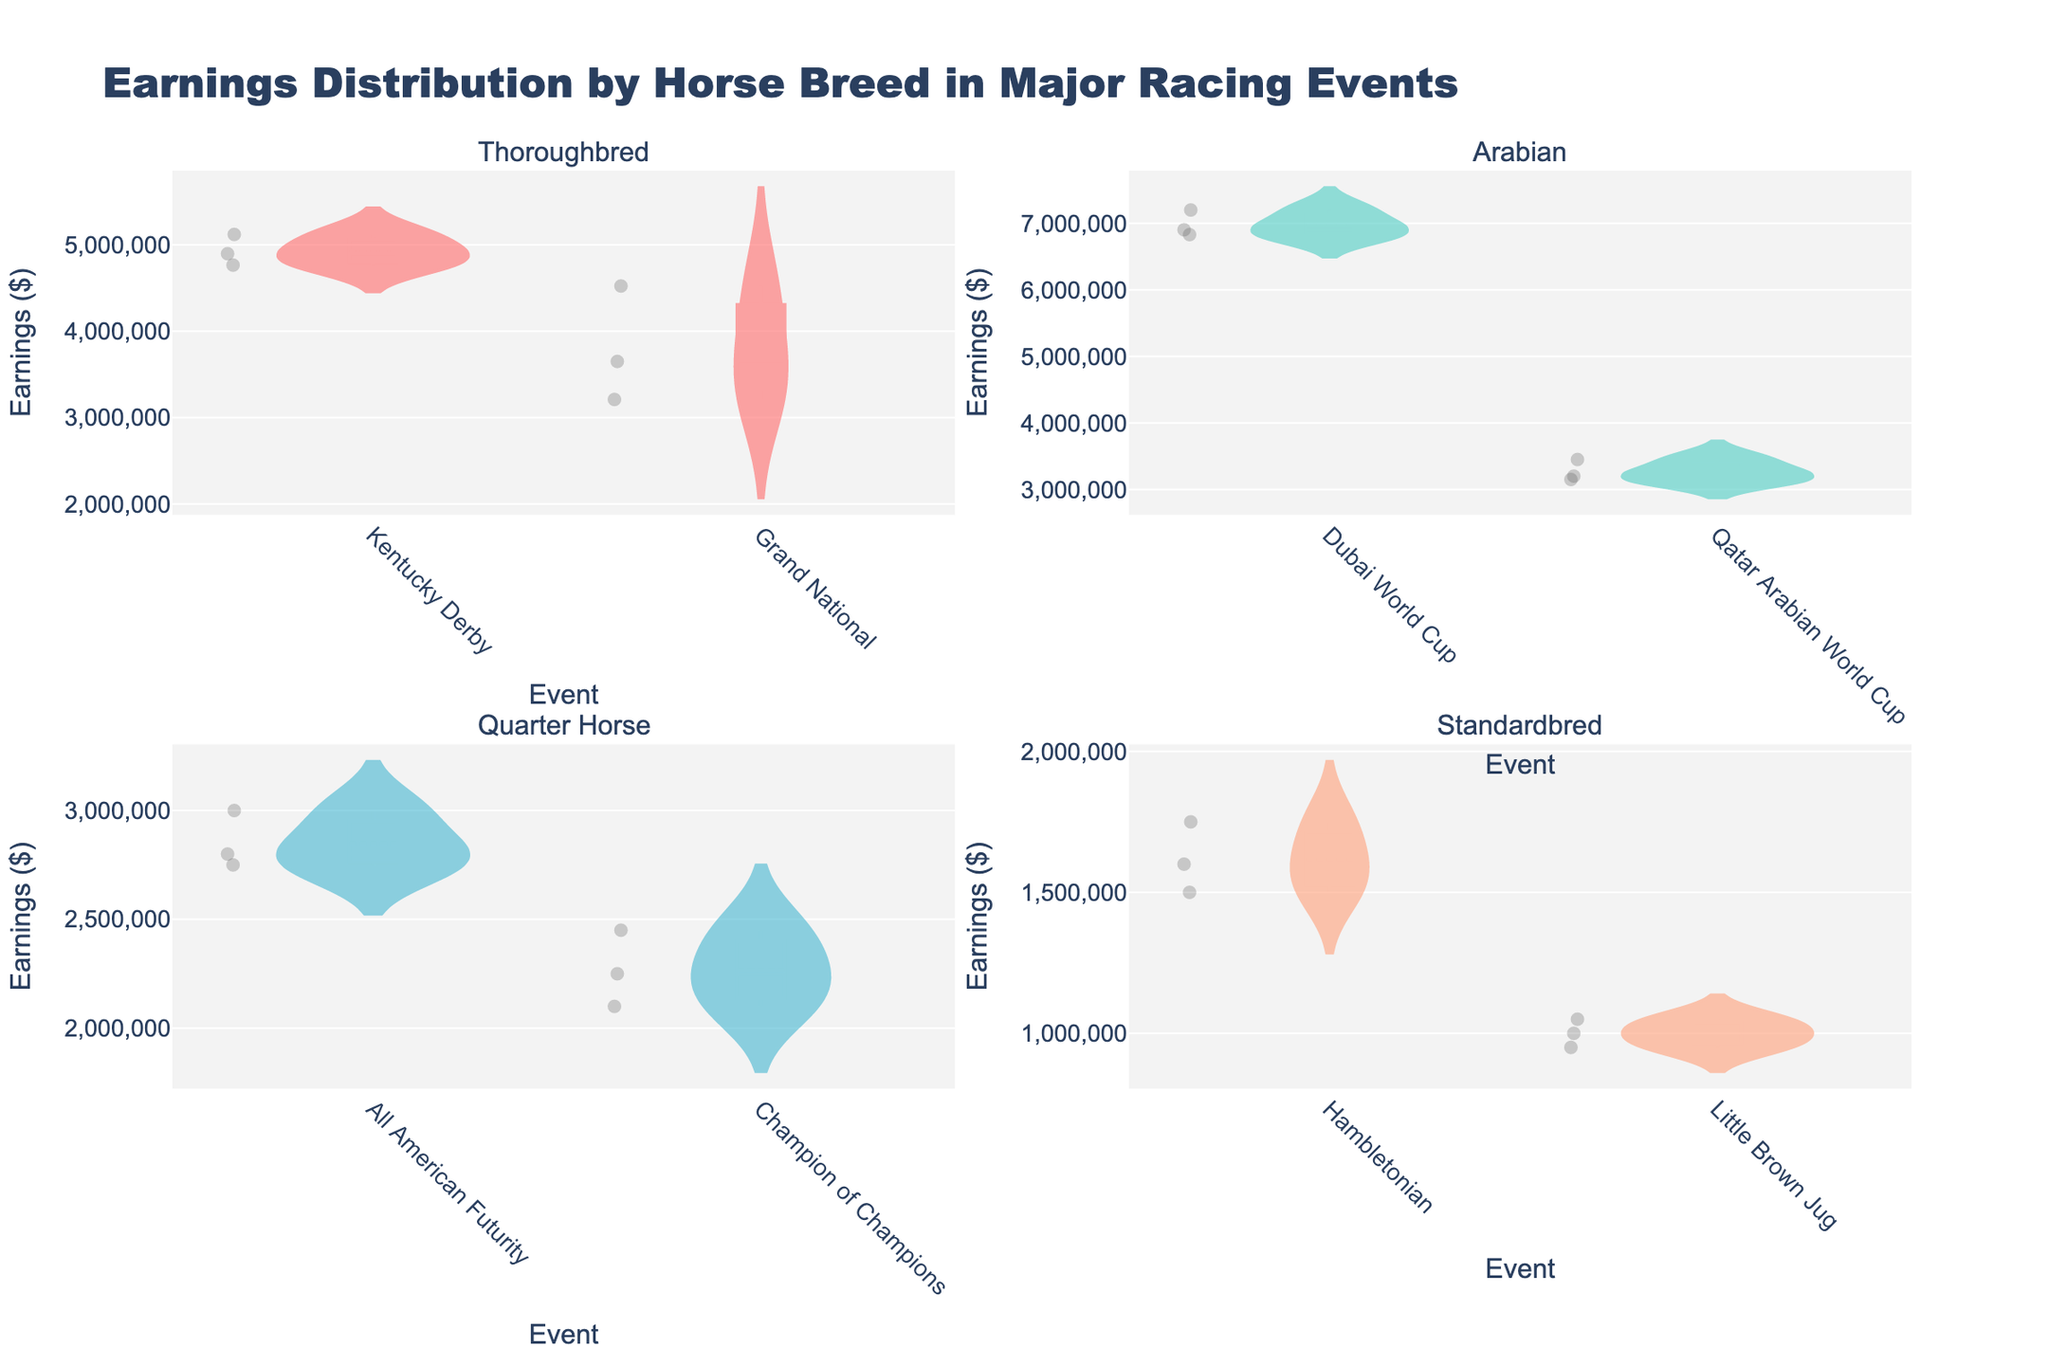How many horse breeds are displayed in the figure? The figure has 2x2 subplots, each representing a different horse breed. The subplot titles indicate the different breeds: Thoroughbred, Arabian, Quarter Horse, and Standardbred. Hence, there are four horse breeds.
Answer: 4 Which event shows the highest earnings distribution for Arabians? By examining the subplots' distribution for each event for Arabian, the Dubai World Cup exhibits higher earnings than the Qatar Arabian World Cup.
Answer: Dubai World Cup What's the median earnings value for Thoroughbreds in the Grand National event? In the Thoroughbred subplot under the Grand National event, the data points are (3210000, 3650000, 4523000). The median is the middle value after sorting: (3210000, 3650000, 4523000), so the median is 3650000.
Answer: 3650000 Compare the average earnings between Thoroughbreds in the Kentucky Derby and Quarter Horses in the All American Futurity. Which has the higher average? For Thoroughbreds in the Kentucky Derby: Average = (5120000 + 4765000 + 4897000) / 3 = 4927333.33. For Quarter Horses in the All American Futurity: Average = (3000000 + 2800000 + 2750000) / 3 = 2850000. The Kentucky Derby Thoroughbreds have higher average earnings.
Answer: Kentucky Derby Thoroughbreds Describe the spread of earnings for Standardbreds in the Hambletonian event. Observing the subplot for Standardbreds in the Hambletonian event, the earnings distribution ranges from 1500000 to 1750000. The violin plot shows a relatively concentrated distribution with a box plot highlighting the median around the central range.
Answer: Concentrated between 1500000 and 1750000 Which event and horse breed combination has the lowest earnings distribution? By examining all subplots, the Little Brown Jug for Standardbreds shows the lowest earning range from 950000 to 1050000.
Answer: Little Brown Jug for Standardbreds Do Arabian horses earn more in the Dubai World Cup than in the Qatar Arabian World Cup? Arabian horses' suggested earnings in the Dubai World Cup range around higher values compared to the earnings in the Qatar Arabian World Cup, implying that the Dubai World Cup generally has higher earnings for Arabian horses.
Answer: Yes Is there a noticeable difference in variability of earnings between the Grand National and Kentucky Derby for Thoroughbreds? The Kentucky Derby for Thoroughbreds shows less variability in earnings, within a close range around 4765000 to 5120000, while the Grand National has a wider earnings spread from 3210000 to 4523000.
Answer: Yes What is the color used to represent Arabian horses in the figure? The subplot for Arabian horses uses a color similar to a turquoise shade which is distinct from the others.
Answer: Turquoise How do the earnings distributions for Quarter Horses in Champion of Champions compare against All American Futurity? Quarter Horses in Champion of Champions show a lower earning distribution range (2100000-2450000) compared to the All American Futurity range (2750000-3000000).
Answer: Lower for Champion of Champions 